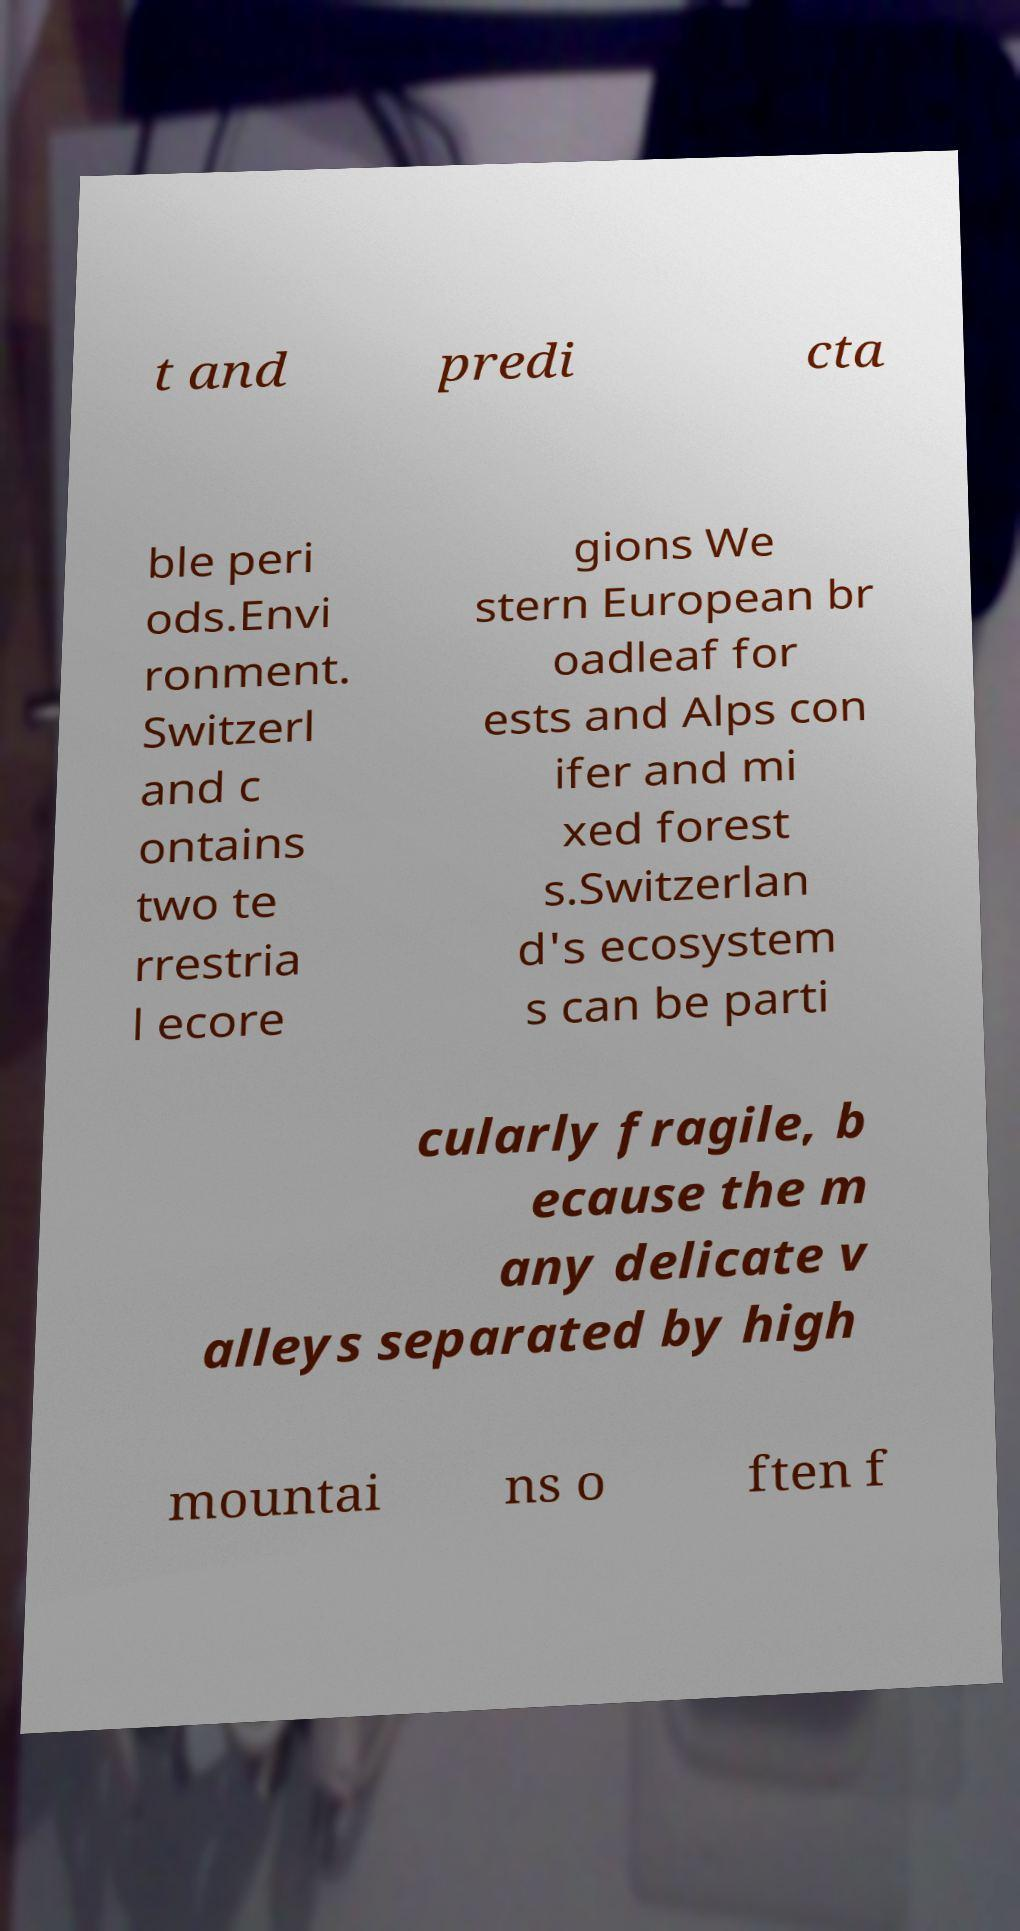Can you accurately transcribe the text from the provided image for me? t and predi cta ble peri ods.Envi ronment. Switzerl and c ontains two te rrestria l ecore gions We stern European br oadleaf for ests and Alps con ifer and mi xed forest s.Switzerlan d's ecosystem s can be parti cularly fragile, b ecause the m any delicate v alleys separated by high mountai ns o ften f 